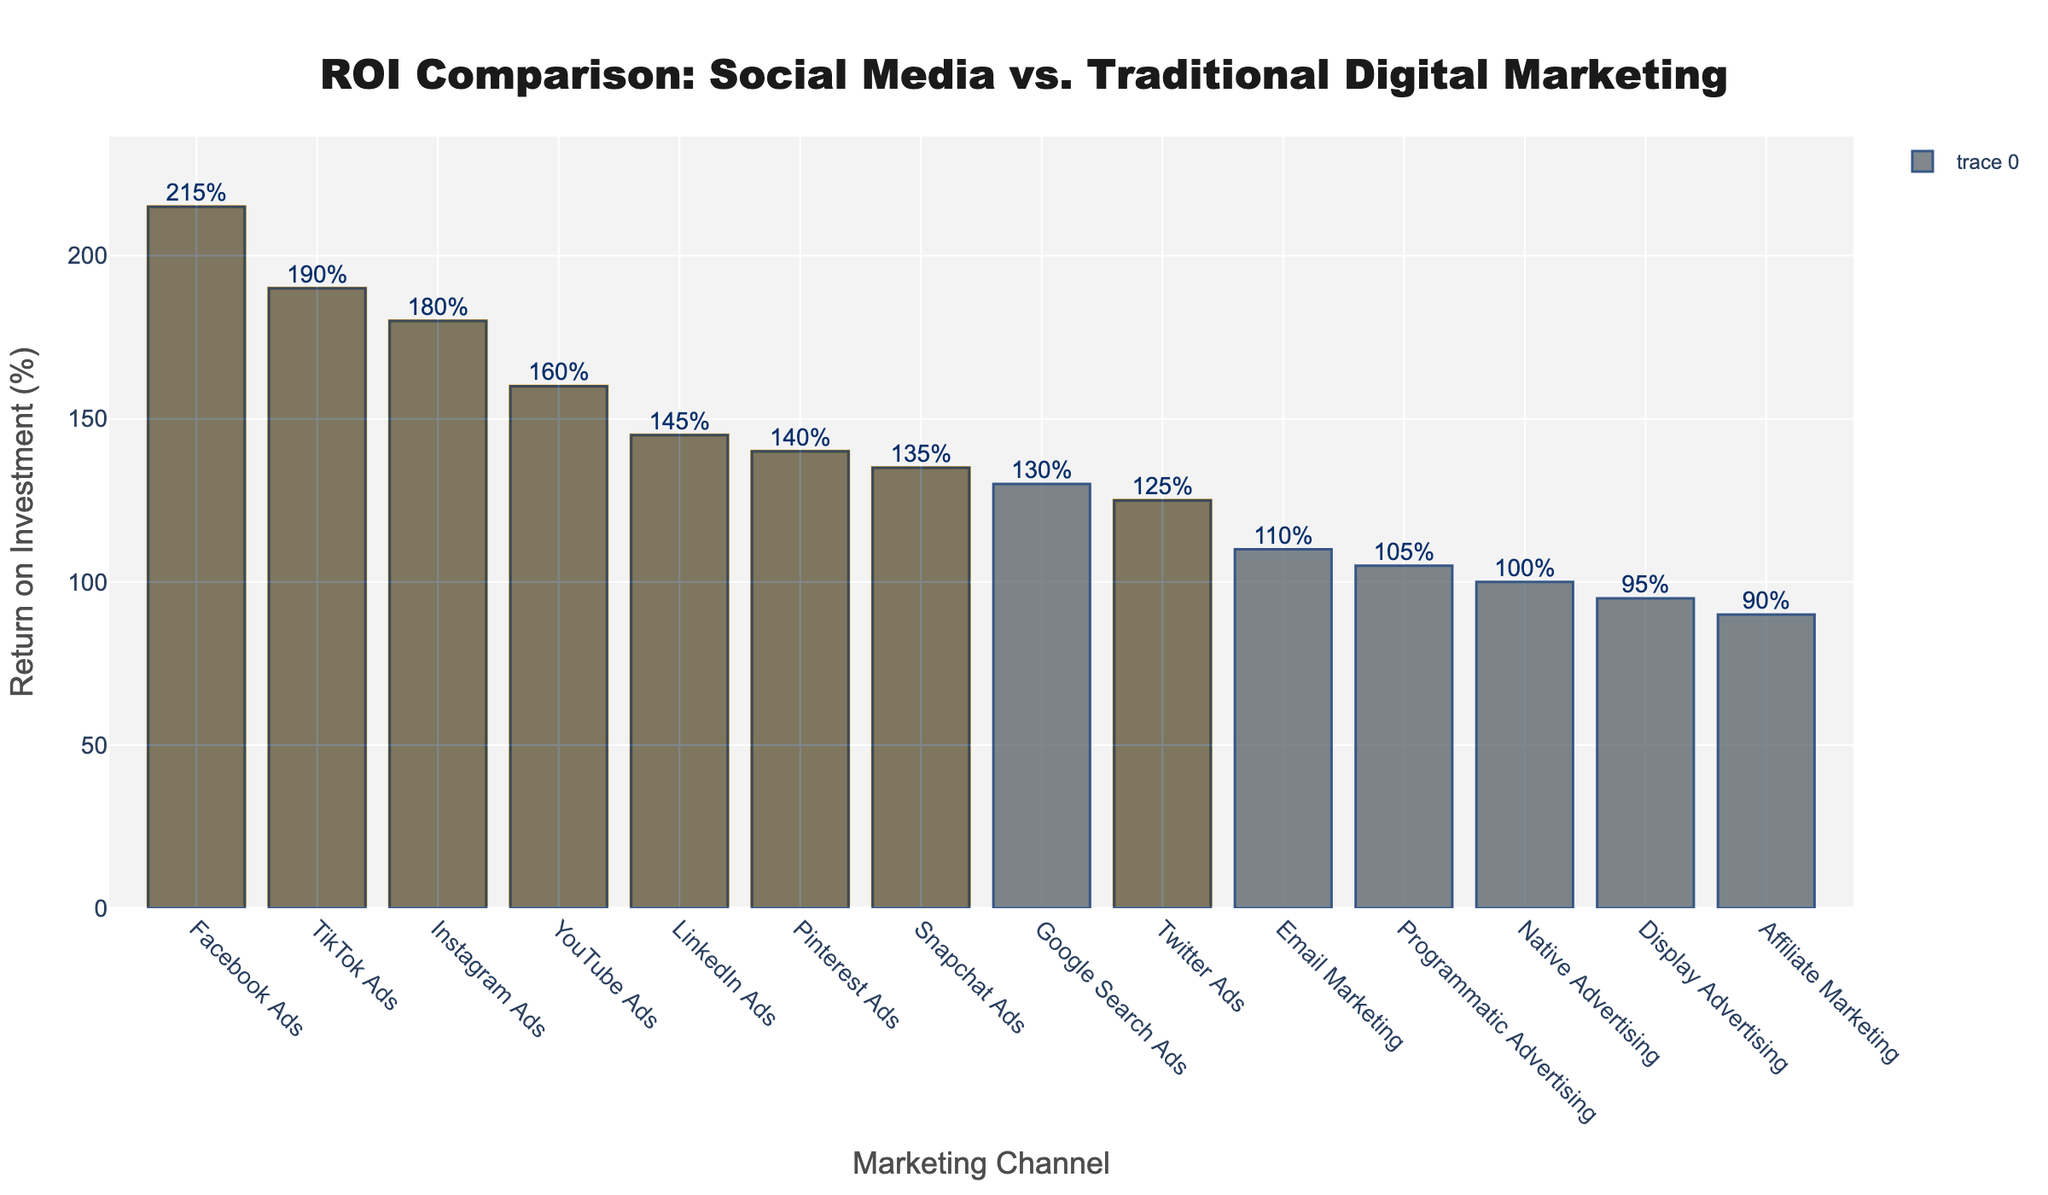What is the ROI of Facebook Ads compared to Google Search Ads? The ROI of Facebook Ads is 215%, and the ROI of Google Search Ads is 130%. By comparing these two values, we can see that the ROI of Facebook Ads is greater than Google Search Ads.
Answer: Facebook Ads has a higher ROI than Google Search Ads Which social media platform has the highest ROI? By observing the highlighted bars representing social media platforms, we see that Facebook Ads, with an ROI of 215%, is the highest among them.
Answer: Facebook Ads What is the sum of the ROIs for TikTok Ads and Instagram Ads? The ROI for TikTok Ads is 190%, and for Instagram Ads, it is 180%. Adding these together yields 190% + 180% = 370%.
Answer: 370% How much higher is the ROI of Facebook Ads compared to the lowest ROI channel? The lowest ROI channel is Affiliate Marketing at 90%. The ROI of Facebook Ads is 215%. The difference is 215% - 90% = 125%.
Answer: 125% Which traditional marketing channel shows the highest ROI, and what is it? Among the non-highlighted bars representing traditional marketing channels, the highest ROI is for Google Search Ads, which has an ROI of 130%.
Answer: Google Search Ads with an ROI of 130% What is the range of ROI values in the figure? The lowest ROI is 90%, and the highest is 215%. The range is calculated as 215% - 90% = 125%.
Answer: 125% Calculate the average ROI of all social media platforms mentioned in the figure. The social media platforms include Facebook Ads (215%), Instagram Ads (180%), LinkedIn Ads (145%), YouTube Ads (160%), Twitter Ads (125%), Pinterest Ads (140%), TikTok Ads (190%), and Snapchat Ads (135%). Adding these together gives 215% + 180% + 145% + 160% + 125% + 140% + 190% + 135% = 1290%. There are 8 social media platforms, so the average is 1290% / 8 = 161.25%.
Answer: 161.25% Are there more social media platforms or traditional digital marketing channels depicted in the figure? There are 8 social media platforms (highlighted bars) and 6 traditional digital marketing channels (non-highlighted bars).
Answer: More social media platforms 